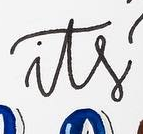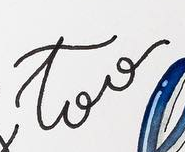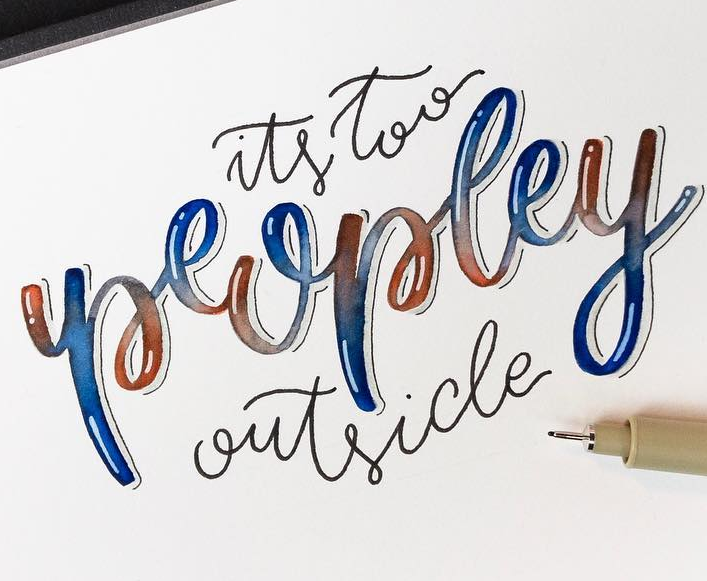What words are shown in these images in order, separated by a semicolon? its; too; peopley 